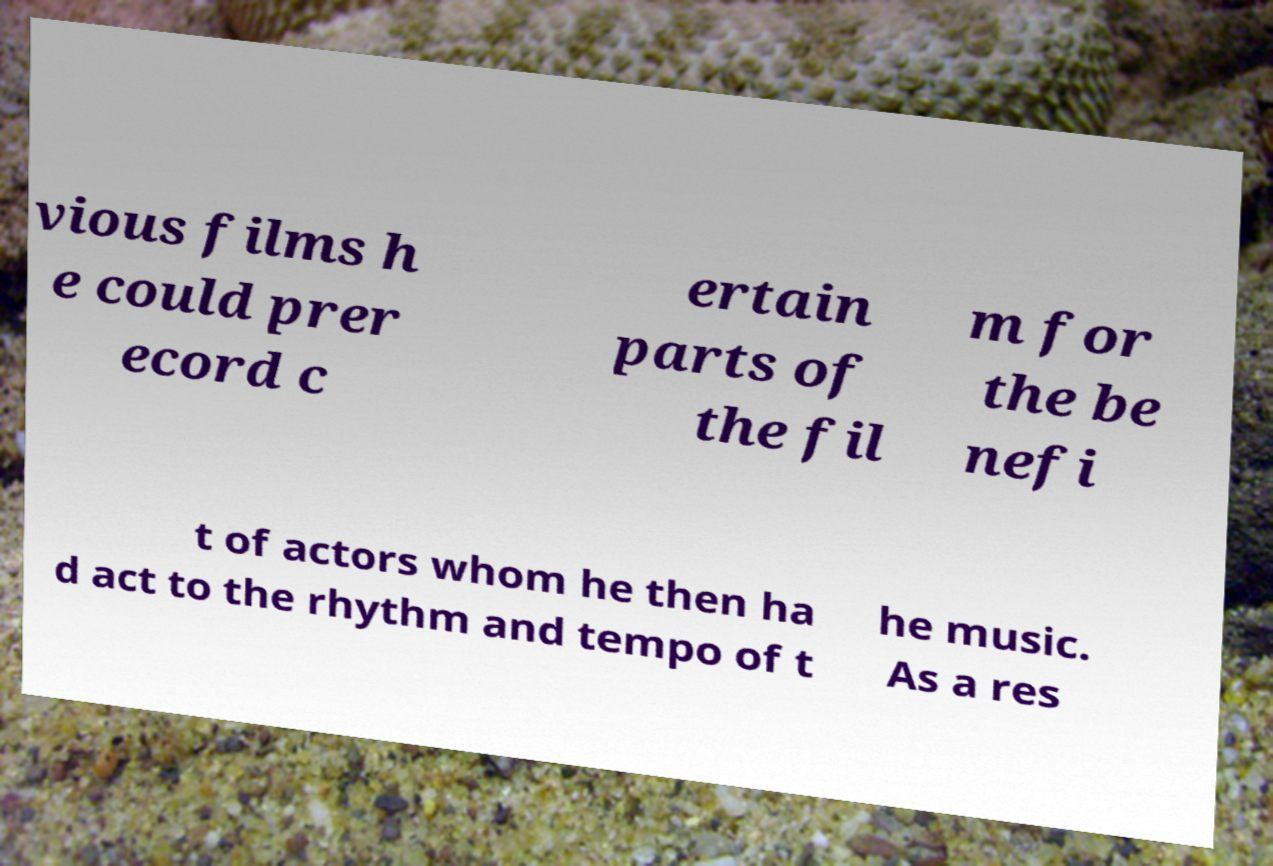I need the written content from this picture converted into text. Can you do that? vious films h e could prer ecord c ertain parts of the fil m for the be nefi t of actors whom he then ha d act to the rhythm and tempo of t he music. As a res 